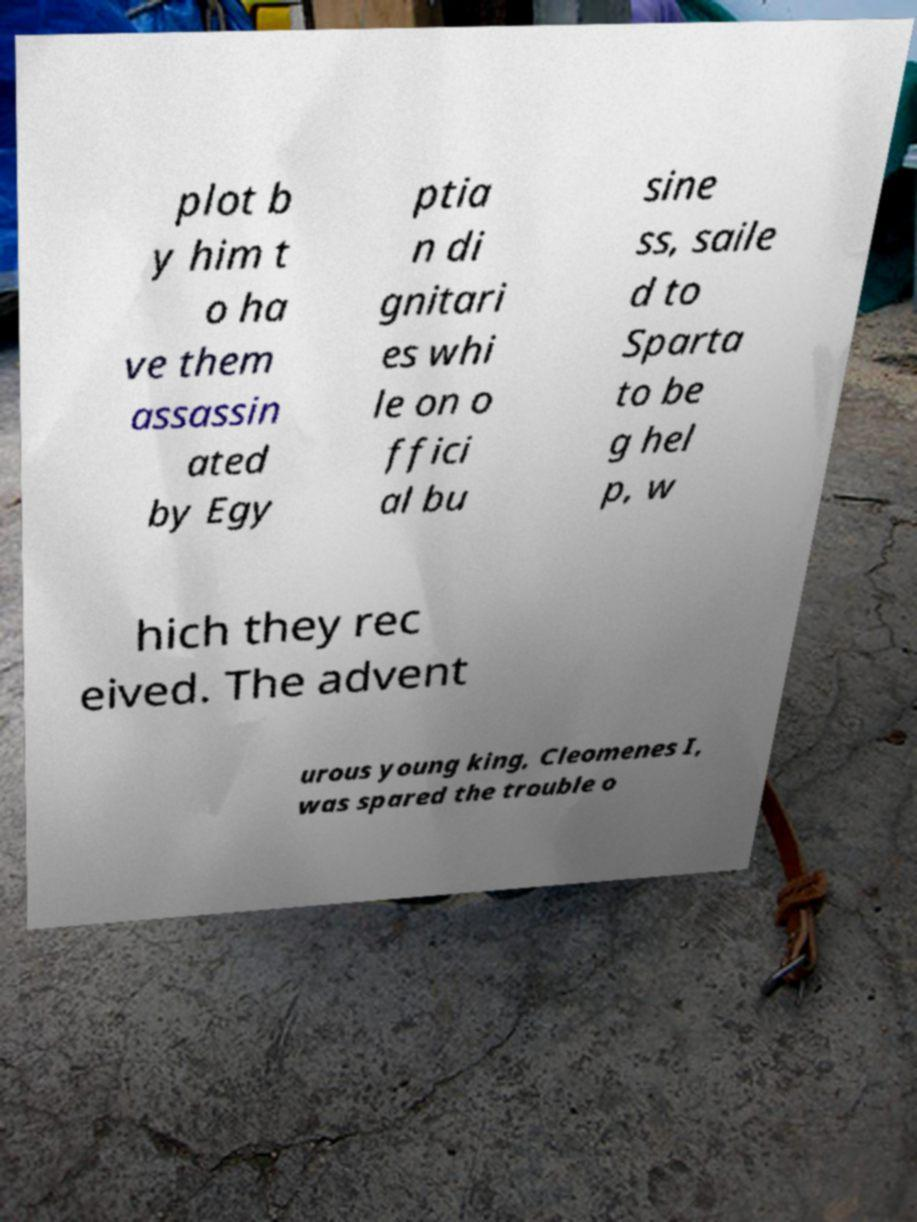For documentation purposes, I need the text within this image transcribed. Could you provide that? plot b y him t o ha ve them assassin ated by Egy ptia n di gnitari es whi le on o ffici al bu sine ss, saile d to Sparta to be g hel p, w hich they rec eived. The advent urous young king, Cleomenes I, was spared the trouble o 